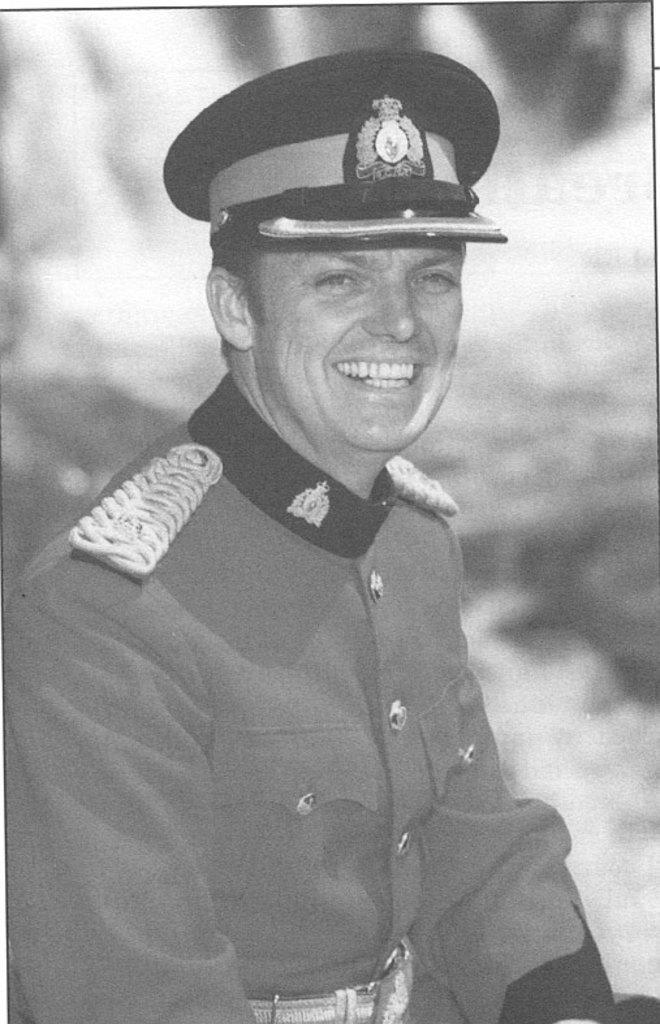What is the main subject of the image? There is a man in the image. What is the man's facial expression? The man is smiling. Can you describe the background of the image? The background of the image is blurry. What type of crayon is the man using to draw in the image? There is no crayon present in the image, and the man is not drawing. What achievements has the man accomplished, as seen in the image? The image does not provide any information about the man's achievements. 